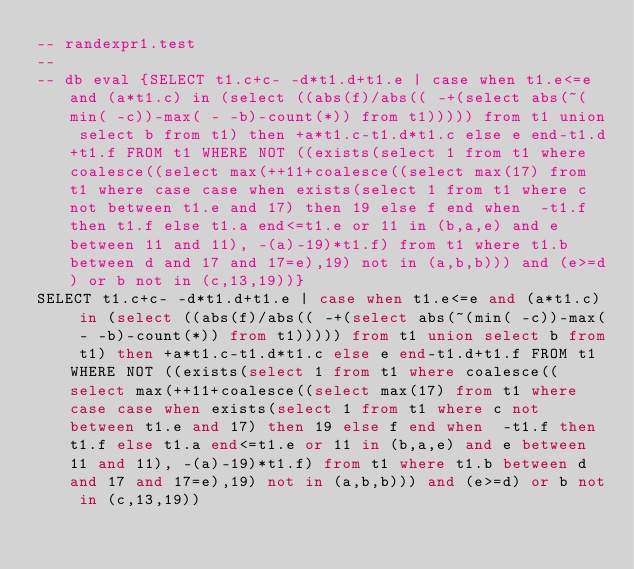<code> <loc_0><loc_0><loc_500><loc_500><_SQL_>-- randexpr1.test
-- 
-- db eval {SELECT t1.c+c- -d*t1.d+t1.e | case when t1.e<=e and (a*t1.c) in (select ((abs(f)/abs(( -+(select abs(~(min( -c))-max( - -b)-count(*)) from t1))))) from t1 union select b from t1) then +a*t1.c-t1.d*t1.c else e end-t1.d+t1.f FROM t1 WHERE NOT ((exists(select 1 from t1 where coalesce((select max(++11+coalesce((select max(17) from t1 where case case when exists(select 1 from t1 where c not between t1.e and 17) then 19 else f end when  -t1.f then t1.f else t1.a end<=t1.e or 11 in (b,a,e) and e between 11 and 11), -(a)-19)*t1.f) from t1 where t1.b between d and 17 and 17=e),19) not in (a,b,b))) and (e>=d) or b not in (c,13,19))}
SELECT t1.c+c- -d*t1.d+t1.e | case when t1.e<=e and (a*t1.c) in (select ((abs(f)/abs(( -+(select abs(~(min( -c))-max( - -b)-count(*)) from t1))))) from t1 union select b from t1) then +a*t1.c-t1.d*t1.c else e end-t1.d+t1.f FROM t1 WHERE NOT ((exists(select 1 from t1 where coalesce((select max(++11+coalesce((select max(17) from t1 where case case when exists(select 1 from t1 where c not between t1.e and 17) then 19 else f end when  -t1.f then t1.f else t1.a end<=t1.e or 11 in (b,a,e) and e between 11 and 11), -(a)-19)*t1.f) from t1 where t1.b between d and 17 and 17=e),19) not in (a,b,b))) and (e>=d) or b not in (c,13,19))</code> 